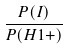Convert formula to latex. <formula><loc_0><loc_0><loc_500><loc_500>\frac { P ( I ) } { P ( H 1 + ) }</formula> 